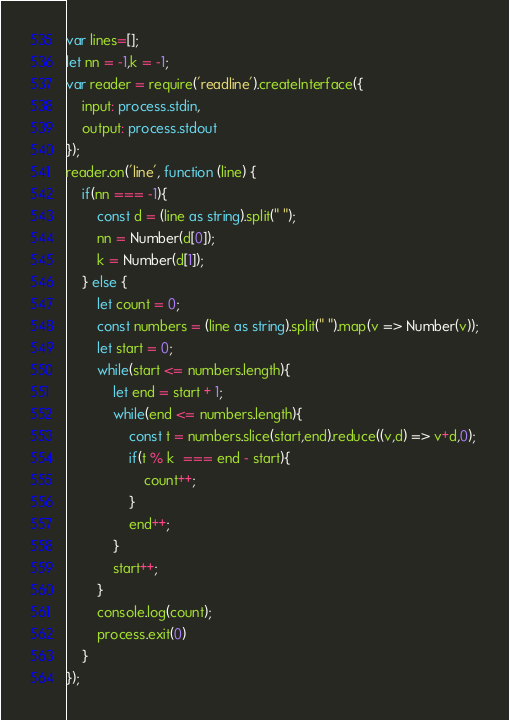Convert code to text. <code><loc_0><loc_0><loc_500><loc_500><_TypeScript_>var lines=[];
let nn = -1,k = -1;
var reader = require('readline').createInterface({
    input: process.stdin,
    output: process.stdout
});
reader.on('line', function (line) {
    if(nn === -1){
        const d = (line as string).split(" ");
        nn = Number(d[0]);
        k = Number(d[1]);
    } else {
        let count = 0;
        const numbers = (line as string).split(" ").map(v => Number(v));
        let start = 0;
        while(start <= numbers.length){
            let end = start + 1;
            while(end <= numbers.length){
                const t = numbers.slice(start,end).reduce((v,d) => v+d,0);
                if(t % k  === end - start){
                    count++;
                }
                end++;
            }
            start++;
        }
        console.log(count);
        process.exit(0)
    }
});</code> 